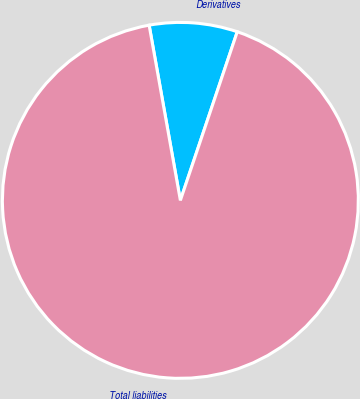Convert chart. <chart><loc_0><loc_0><loc_500><loc_500><pie_chart><fcel>Derivatives<fcel>Total liabilities<nl><fcel>7.99%<fcel>92.01%<nl></chart> 